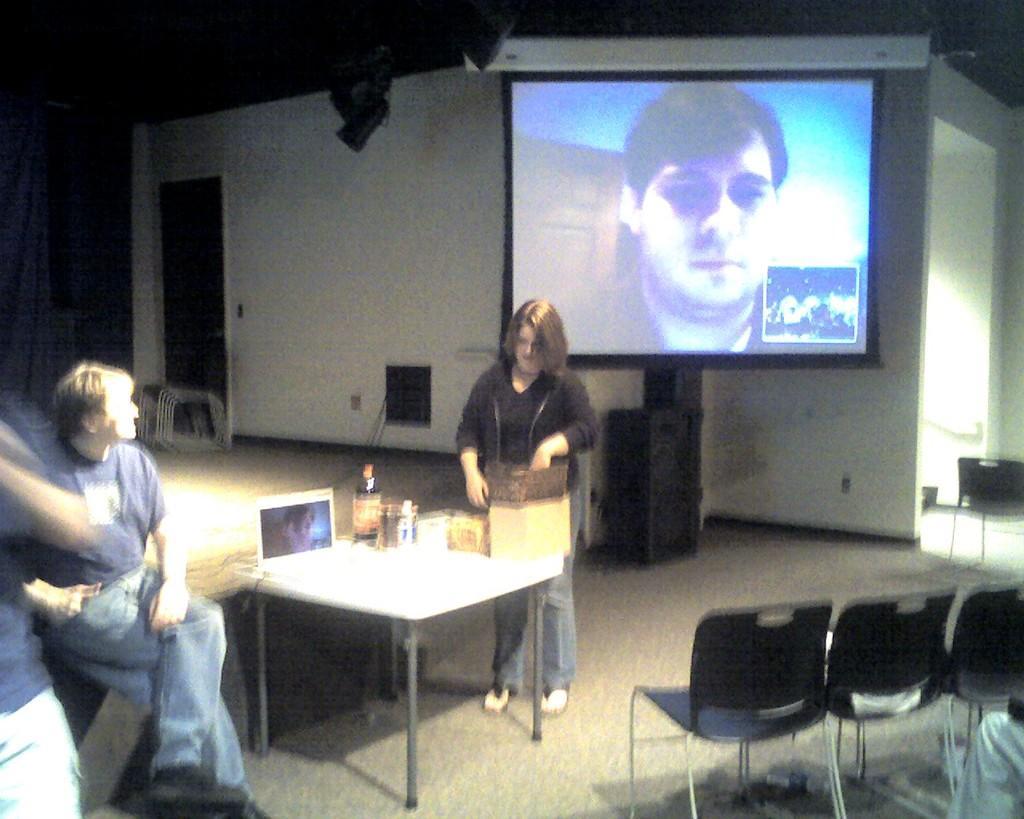Please provide a concise description of this image. In this image a woman is standing before a table. Behind her there is a screen having a person in it. At the left side there are two persons, one person is sitting is wearing a blue shirt and jeans. At the right side there are three chairs. On table there is bottle and laptop. 